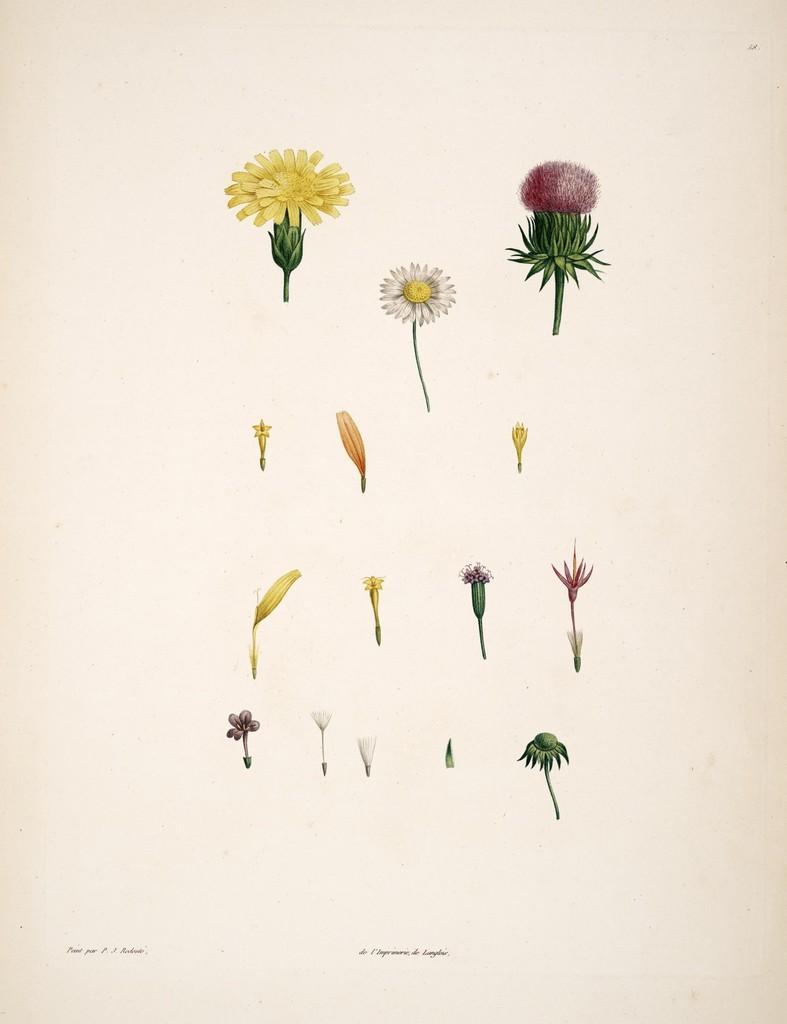Please provide a concise description of this image. In this image there are some flowers. 